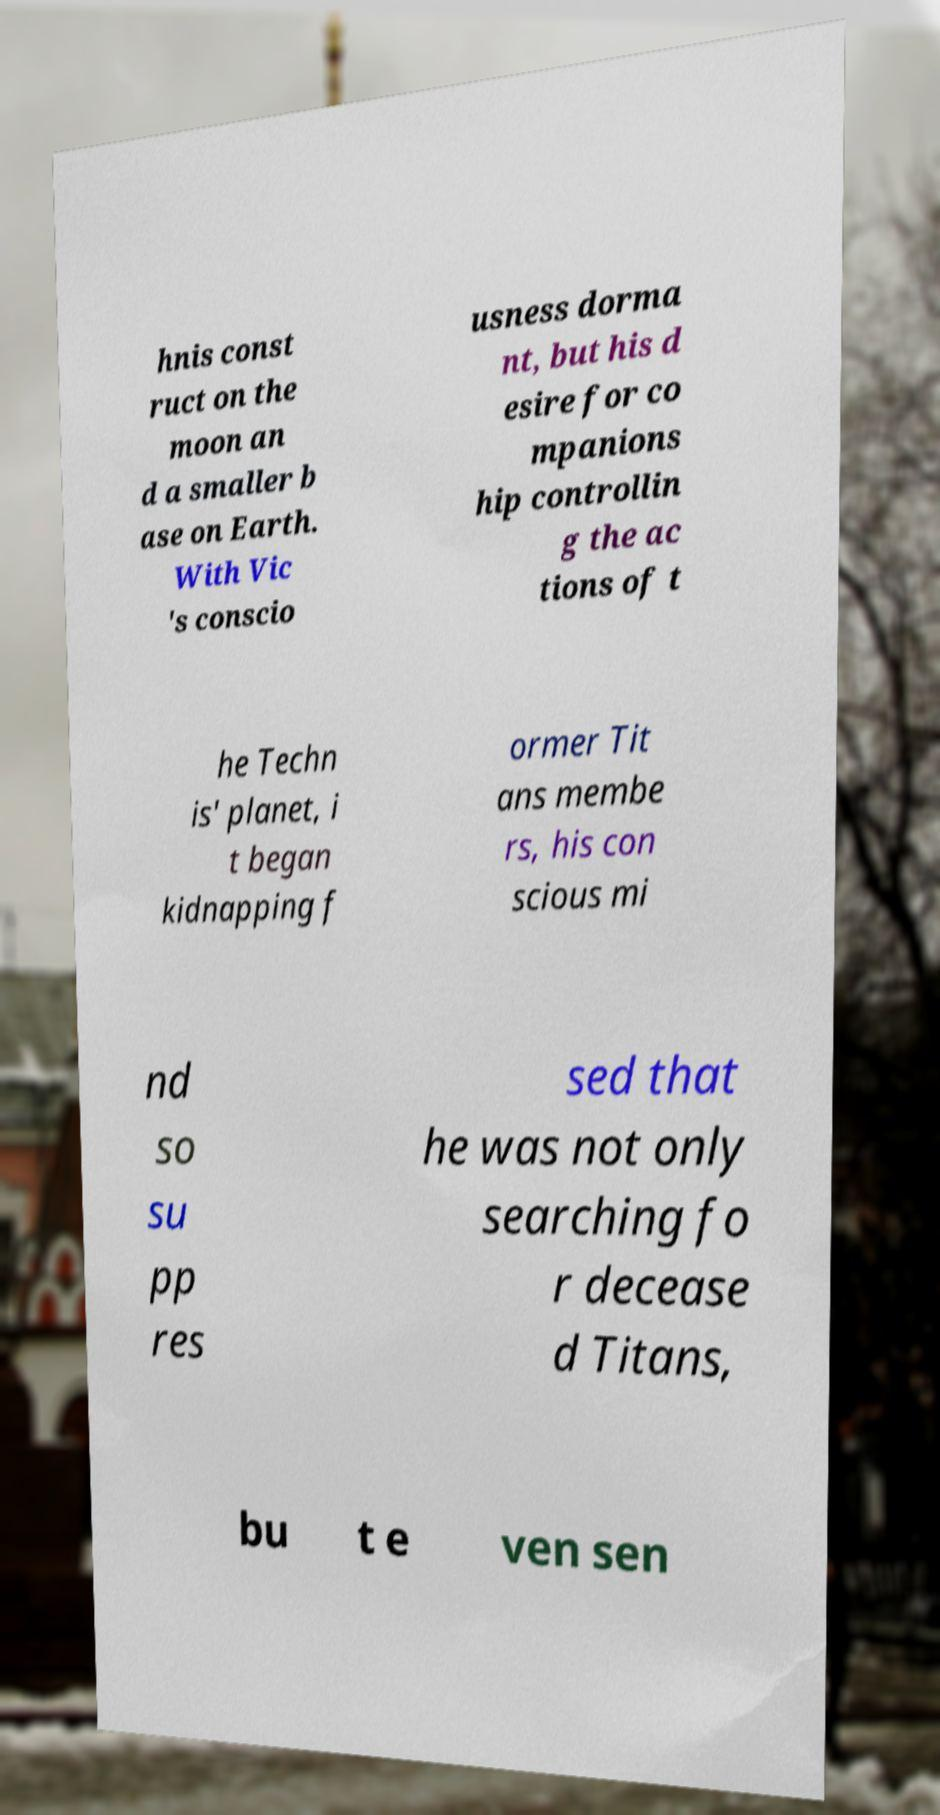I need the written content from this picture converted into text. Can you do that? hnis const ruct on the moon an d a smaller b ase on Earth. With Vic 's conscio usness dorma nt, but his d esire for co mpanions hip controllin g the ac tions of t he Techn is' planet, i t began kidnapping f ormer Tit ans membe rs, his con scious mi nd so su pp res sed that he was not only searching fo r decease d Titans, bu t e ven sen 